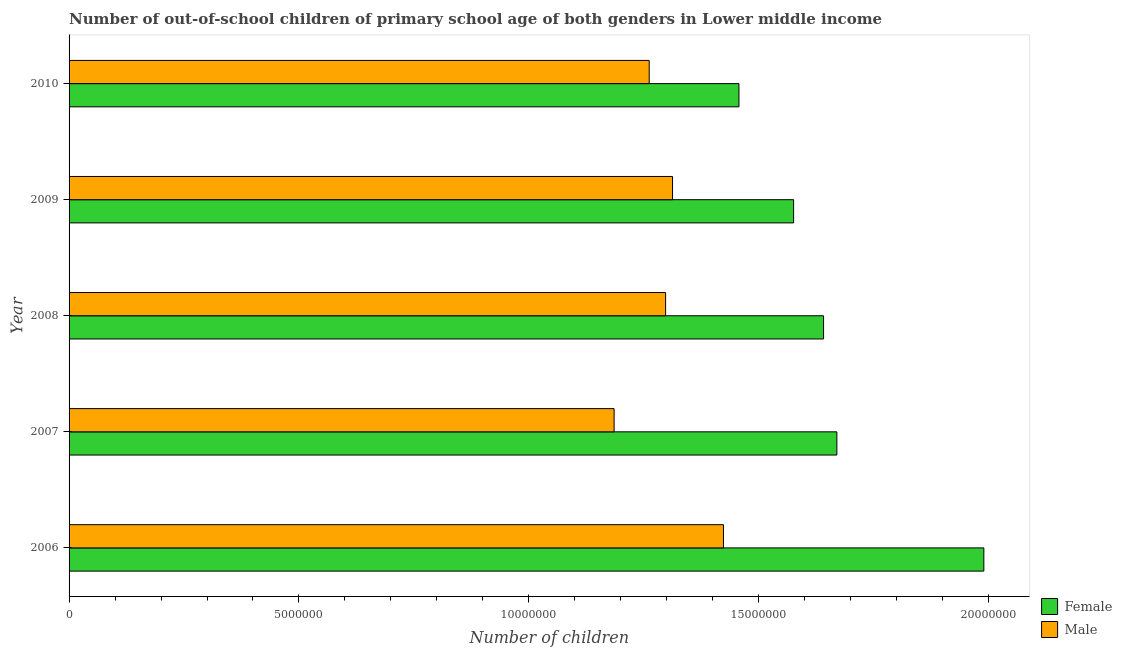How many different coloured bars are there?
Provide a short and direct response. 2. How many groups of bars are there?
Offer a very short reply. 5. Are the number of bars on each tick of the Y-axis equal?
Provide a short and direct response. Yes. How many bars are there on the 4th tick from the top?
Provide a short and direct response. 2. How many bars are there on the 3rd tick from the bottom?
Give a very brief answer. 2. In how many cases, is the number of bars for a given year not equal to the number of legend labels?
Give a very brief answer. 0. What is the number of male out-of-school students in 2007?
Provide a short and direct response. 1.19e+07. Across all years, what is the maximum number of female out-of-school students?
Give a very brief answer. 1.99e+07. Across all years, what is the minimum number of female out-of-school students?
Offer a very short reply. 1.46e+07. In which year was the number of female out-of-school students maximum?
Provide a succinct answer. 2006. What is the total number of male out-of-school students in the graph?
Offer a terse response. 6.48e+07. What is the difference between the number of male out-of-school students in 2006 and that in 2008?
Provide a short and direct response. 1.26e+06. What is the difference between the number of male out-of-school students in 2006 and the number of female out-of-school students in 2010?
Give a very brief answer. -3.37e+05. What is the average number of female out-of-school students per year?
Offer a very short reply. 1.67e+07. In the year 2010, what is the difference between the number of male out-of-school students and number of female out-of-school students?
Provide a short and direct response. -1.95e+06. Is the number of female out-of-school students in 2008 less than that in 2009?
Give a very brief answer. No. Is the difference between the number of male out-of-school students in 2006 and 2007 greater than the difference between the number of female out-of-school students in 2006 and 2007?
Offer a terse response. No. What is the difference between the highest and the second highest number of male out-of-school students?
Your response must be concise. 1.11e+06. What is the difference between the highest and the lowest number of female out-of-school students?
Your response must be concise. 5.33e+06. Is the sum of the number of male out-of-school students in 2007 and 2009 greater than the maximum number of female out-of-school students across all years?
Offer a very short reply. Yes. What does the 2nd bar from the top in 2010 represents?
Offer a terse response. Female. How many bars are there?
Keep it short and to the point. 10. How many years are there in the graph?
Keep it short and to the point. 5. What is the difference between two consecutive major ticks on the X-axis?
Offer a very short reply. 5.00e+06. Are the values on the major ticks of X-axis written in scientific E-notation?
Give a very brief answer. No. Does the graph contain grids?
Your answer should be very brief. No. Where does the legend appear in the graph?
Offer a very short reply. Bottom right. How are the legend labels stacked?
Give a very brief answer. Vertical. What is the title of the graph?
Give a very brief answer. Number of out-of-school children of primary school age of both genders in Lower middle income. What is the label or title of the X-axis?
Keep it short and to the point. Number of children. What is the Number of children of Female in 2006?
Make the answer very short. 1.99e+07. What is the Number of children in Male in 2006?
Ensure brevity in your answer.  1.42e+07. What is the Number of children in Female in 2007?
Provide a succinct answer. 1.67e+07. What is the Number of children of Male in 2007?
Give a very brief answer. 1.19e+07. What is the Number of children of Female in 2008?
Provide a succinct answer. 1.64e+07. What is the Number of children in Male in 2008?
Keep it short and to the point. 1.30e+07. What is the Number of children in Female in 2009?
Give a very brief answer. 1.58e+07. What is the Number of children in Male in 2009?
Make the answer very short. 1.31e+07. What is the Number of children of Female in 2010?
Provide a short and direct response. 1.46e+07. What is the Number of children in Male in 2010?
Provide a short and direct response. 1.26e+07. Across all years, what is the maximum Number of children in Female?
Your answer should be compact. 1.99e+07. Across all years, what is the maximum Number of children of Male?
Your answer should be very brief. 1.42e+07. Across all years, what is the minimum Number of children of Female?
Your answer should be compact. 1.46e+07. Across all years, what is the minimum Number of children of Male?
Provide a succinct answer. 1.19e+07. What is the total Number of children of Female in the graph?
Offer a terse response. 8.33e+07. What is the total Number of children in Male in the graph?
Offer a terse response. 6.48e+07. What is the difference between the Number of children of Female in 2006 and that in 2007?
Your answer should be compact. 3.20e+06. What is the difference between the Number of children of Male in 2006 and that in 2007?
Your answer should be compact. 2.38e+06. What is the difference between the Number of children in Female in 2006 and that in 2008?
Offer a terse response. 3.49e+06. What is the difference between the Number of children of Male in 2006 and that in 2008?
Your answer should be compact. 1.26e+06. What is the difference between the Number of children in Female in 2006 and that in 2009?
Provide a short and direct response. 4.14e+06. What is the difference between the Number of children in Male in 2006 and that in 2009?
Make the answer very short. 1.11e+06. What is the difference between the Number of children of Female in 2006 and that in 2010?
Keep it short and to the point. 5.33e+06. What is the difference between the Number of children of Male in 2006 and that in 2010?
Offer a terse response. 1.61e+06. What is the difference between the Number of children in Female in 2007 and that in 2008?
Your answer should be compact. 2.89e+05. What is the difference between the Number of children in Male in 2007 and that in 2008?
Provide a succinct answer. -1.12e+06. What is the difference between the Number of children of Female in 2007 and that in 2009?
Provide a short and direct response. 9.41e+05. What is the difference between the Number of children of Male in 2007 and that in 2009?
Your answer should be compact. -1.27e+06. What is the difference between the Number of children of Female in 2007 and that in 2010?
Offer a very short reply. 2.13e+06. What is the difference between the Number of children in Male in 2007 and that in 2010?
Ensure brevity in your answer.  -7.64e+05. What is the difference between the Number of children in Female in 2008 and that in 2009?
Your answer should be very brief. 6.51e+05. What is the difference between the Number of children in Male in 2008 and that in 2009?
Your answer should be very brief. -1.50e+05. What is the difference between the Number of children of Female in 2008 and that in 2010?
Ensure brevity in your answer.  1.84e+06. What is the difference between the Number of children in Male in 2008 and that in 2010?
Offer a very short reply. 3.57e+05. What is the difference between the Number of children of Female in 2009 and that in 2010?
Your answer should be compact. 1.19e+06. What is the difference between the Number of children in Male in 2009 and that in 2010?
Your answer should be very brief. 5.07e+05. What is the difference between the Number of children of Female in 2006 and the Number of children of Male in 2007?
Make the answer very short. 8.04e+06. What is the difference between the Number of children in Female in 2006 and the Number of children in Male in 2008?
Make the answer very short. 6.92e+06. What is the difference between the Number of children of Female in 2006 and the Number of children of Male in 2009?
Keep it short and to the point. 6.77e+06. What is the difference between the Number of children of Female in 2006 and the Number of children of Male in 2010?
Give a very brief answer. 7.28e+06. What is the difference between the Number of children of Female in 2007 and the Number of children of Male in 2008?
Offer a very short reply. 3.72e+06. What is the difference between the Number of children in Female in 2007 and the Number of children in Male in 2009?
Make the answer very short. 3.57e+06. What is the difference between the Number of children in Female in 2007 and the Number of children in Male in 2010?
Ensure brevity in your answer.  4.08e+06. What is the difference between the Number of children of Female in 2008 and the Number of children of Male in 2009?
Give a very brief answer. 3.28e+06. What is the difference between the Number of children of Female in 2008 and the Number of children of Male in 2010?
Keep it short and to the point. 3.79e+06. What is the difference between the Number of children of Female in 2009 and the Number of children of Male in 2010?
Ensure brevity in your answer.  3.14e+06. What is the average Number of children in Female per year?
Your answer should be compact. 1.67e+07. What is the average Number of children of Male per year?
Provide a succinct answer. 1.30e+07. In the year 2006, what is the difference between the Number of children of Female and Number of children of Male?
Your response must be concise. 5.66e+06. In the year 2007, what is the difference between the Number of children of Female and Number of children of Male?
Ensure brevity in your answer.  4.84e+06. In the year 2008, what is the difference between the Number of children in Female and Number of children in Male?
Provide a succinct answer. 3.44e+06. In the year 2009, what is the difference between the Number of children of Female and Number of children of Male?
Offer a very short reply. 2.63e+06. In the year 2010, what is the difference between the Number of children of Female and Number of children of Male?
Keep it short and to the point. 1.95e+06. What is the ratio of the Number of children in Female in 2006 to that in 2007?
Your response must be concise. 1.19. What is the ratio of the Number of children in Male in 2006 to that in 2007?
Offer a very short reply. 1.2. What is the ratio of the Number of children of Female in 2006 to that in 2008?
Your answer should be very brief. 1.21. What is the ratio of the Number of children in Male in 2006 to that in 2008?
Keep it short and to the point. 1.1. What is the ratio of the Number of children in Female in 2006 to that in 2009?
Provide a succinct answer. 1.26. What is the ratio of the Number of children of Male in 2006 to that in 2009?
Ensure brevity in your answer.  1.08. What is the ratio of the Number of children in Female in 2006 to that in 2010?
Ensure brevity in your answer.  1.37. What is the ratio of the Number of children of Male in 2006 to that in 2010?
Offer a terse response. 1.13. What is the ratio of the Number of children in Female in 2007 to that in 2008?
Provide a succinct answer. 1.02. What is the ratio of the Number of children of Male in 2007 to that in 2008?
Offer a terse response. 0.91. What is the ratio of the Number of children of Female in 2007 to that in 2009?
Give a very brief answer. 1.06. What is the ratio of the Number of children of Male in 2007 to that in 2009?
Give a very brief answer. 0.9. What is the ratio of the Number of children in Female in 2007 to that in 2010?
Provide a short and direct response. 1.15. What is the ratio of the Number of children of Male in 2007 to that in 2010?
Make the answer very short. 0.94. What is the ratio of the Number of children in Female in 2008 to that in 2009?
Keep it short and to the point. 1.04. What is the ratio of the Number of children in Male in 2008 to that in 2009?
Provide a short and direct response. 0.99. What is the ratio of the Number of children in Female in 2008 to that in 2010?
Keep it short and to the point. 1.13. What is the ratio of the Number of children in Male in 2008 to that in 2010?
Offer a terse response. 1.03. What is the ratio of the Number of children in Female in 2009 to that in 2010?
Give a very brief answer. 1.08. What is the ratio of the Number of children in Male in 2009 to that in 2010?
Offer a terse response. 1.04. What is the difference between the highest and the second highest Number of children of Female?
Ensure brevity in your answer.  3.20e+06. What is the difference between the highest and the second highest Number of children of Male?
Your answer should be compact. 1.11e+06. What is the difference between the highest and the lowest Number of children in Female?
Offer a very short reply. 5.33e+06. What is the difference between the highest and the lowest Number of children in Male?
Make the answer very short. 2.38e+06. 